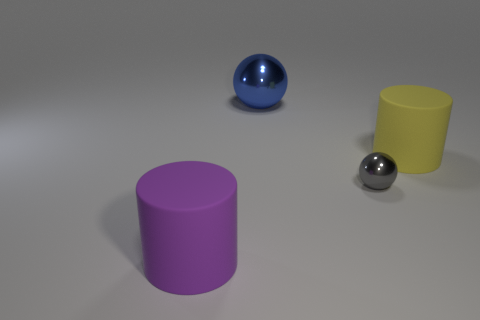There is a big matte thing to the left of the tiny gray shiny thing; does it have the same color as the tiny object?
Offer a very short reply. No. What color is the large shiny thing?
Offer a very short reply. Blue. Are there any metal objects right of the large rubber cylinder that is to the right of the large purple cylinder?
Your answer should be compact. No. What shape is the blue shiny thing that is behind the big cylinder to the right of the blue thing?
Give a very brief answer. Sphere. Is the number of green shiny cylinders less than the number of tiny gray spheres?
Make the answer very short. Yes. Are the big blue object and the tiny gray thing made of the same material?
Your answer should be very brief. Yes. There is a object that is both in front of the large blue metal sphere and behind the small metal sphere; what is its color?
Offer a terse response. Yellow. Is there a blue sphere that has the same size as the purple thing?
Your answer should be very brief. Yes. What size is the rubber cylinder on the left side of the big rubber object right of the big ball?
Offer a terse response. Large. Is the number of large objects that are on the right side of the big yellow rubber thing less than the number of big yellow cylinders?
Provide a short and direct response. Yes. 